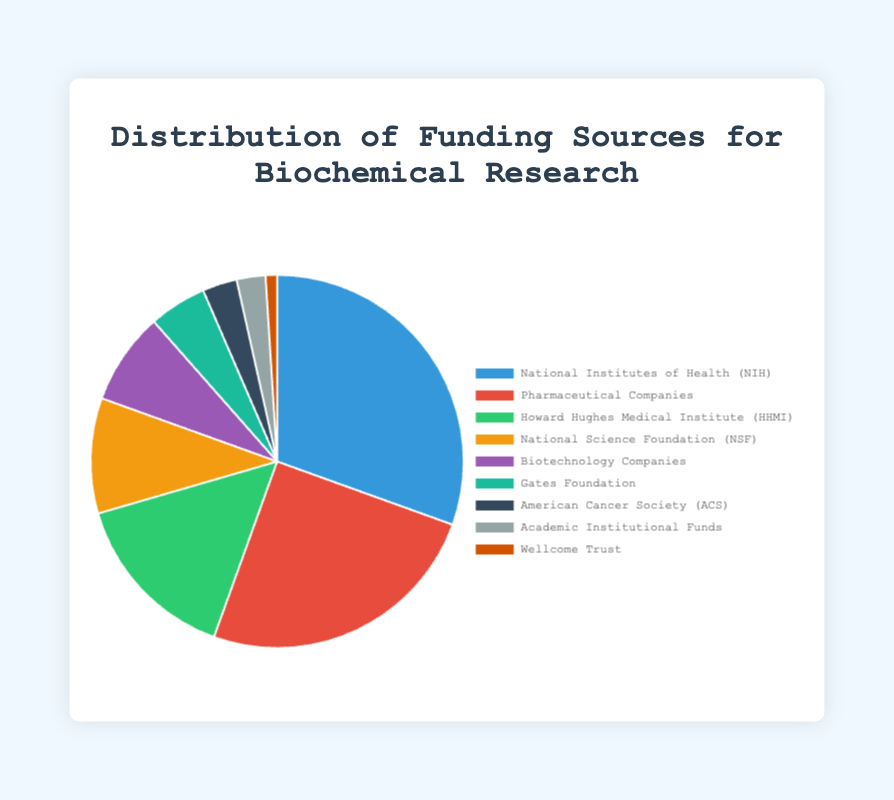Which funding source contributes the highest percentage to biochemical research? The pie chart shows different sectors with their respective percentages. The 'National Institutes of Health (NIH)' segment is the largest, signifying that it contributes the highest percentage.
Answer: National Institutes of Health (NIH) What is the combined percentage contribution from the National Science Foundation (NSF) and the Gates Foundation? The chart indicates that NSF contributes 10.0% and the Gates Foundation contributes 5.0%. Adding these gives 10.0 + 5.0.
Answer: 15.0% Which funding source has the smallest percentage contribution? Observing the pie chart, the smallest segment corresponds to the 'Wellcome Trust', marked at 1.0%.
Answer: Wellcome Trust How much more does the NIH contribute compared to Pharmaceutical Companies? NIH's contribution is 30.5% and Pharmaceutical Companies contribute 25.0%. Subtracting the smaller from the larger value, 30.5 - 25.0.
Answer: 5.5% What is the total percentage contribution from private industry sources? Pharmaceutical Companies contribute 25.0% and Biotechnology Companies contribute 8.0%. Adding these, 25.0 + 8.0.
Answer: 33.0% Are government grants contributing more than non-profit organizations? Summing government grants (NIH: 30.5%, NSF: 10.0%) vs. non-profit organizations (HHMI: 15.0%, Gates Foundation: 5.0%, ACS: 3.0%, Wellcome Trust: 1.0%). For government: 30.5 + 10.0 = 40.5%, for non-profit: 15.0 + 5.0 + 3.0 + 1.0 = 24.0%. Yes, because 40.5% > 24.0%.
Answer: Yes How does the contribution from academic institutions compare with that from the American Cancer Society (ACS)? The chart shows Academic Institutional Funds at 2.5% and ACS at 3.0%. Comparing these values: 2.5 < 3.0.
Answer: Less What percentage of funding comes from non-profit organizations alone? Adding percentages from HHMI (15.0%), Gates Foundation (5.0%), ACS (3.0%), and Wellcome Trust (1.0%): 15.0 + 5.0 + 3.0 + 1.0.
Answer: 24.0% What is the average percentage contribution from all funding sources? Adding all contributions and dividing by the number of sources: (30.5 + 25.0 + 15.0 + 10.0 + 8.0 + 5.0 + 3.0 + 2.5 + 1.0) / 9. Sum is 100.0 and dividing by 9 gives 100.0 / 9.
Answer: 11.1% Which funding source is represented by the green color in the pie chart? The chart's legend indicates that the green segment corresponds to the 'Howard Hughes Medical Institute (HHMI)'.
Answer: Howard Hughes Medical Institute (HHMI) 